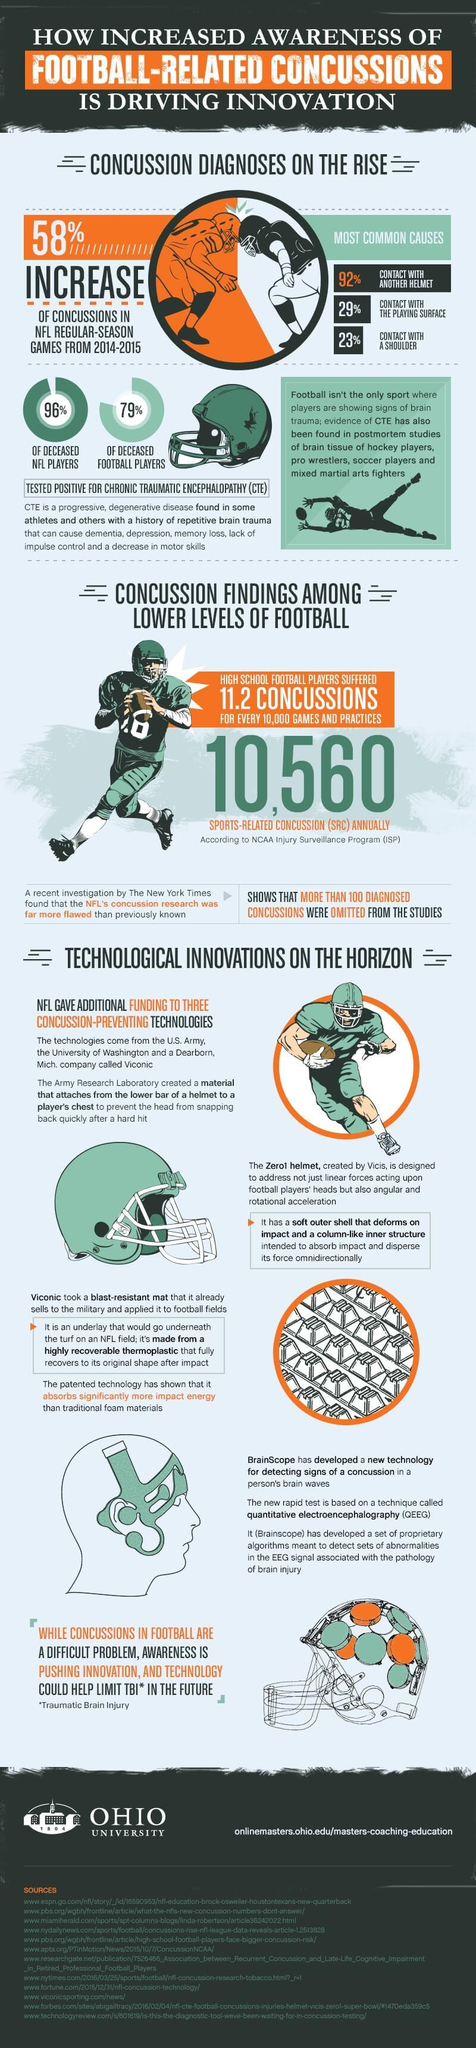Mention a couple of crucial points in this snapshot. It is estimated that more than 100 concussions were omitted from the NFL's concussion research studies. The United States Army, in collaboration with Washington University and Viconic, has developed a number of innovative technologies designed to prevent concussions. These technologies represent a significant advance in the field of sports medicine and are expected to have a significant impact on the safety and well-being of athletes at all levels. The most common cause of concussion in football games is contact with another person's helmet. The New York Times' findings exposed the flaws in the NFL's research on concussions. The number of concussions in NFL games increased by 58%. 